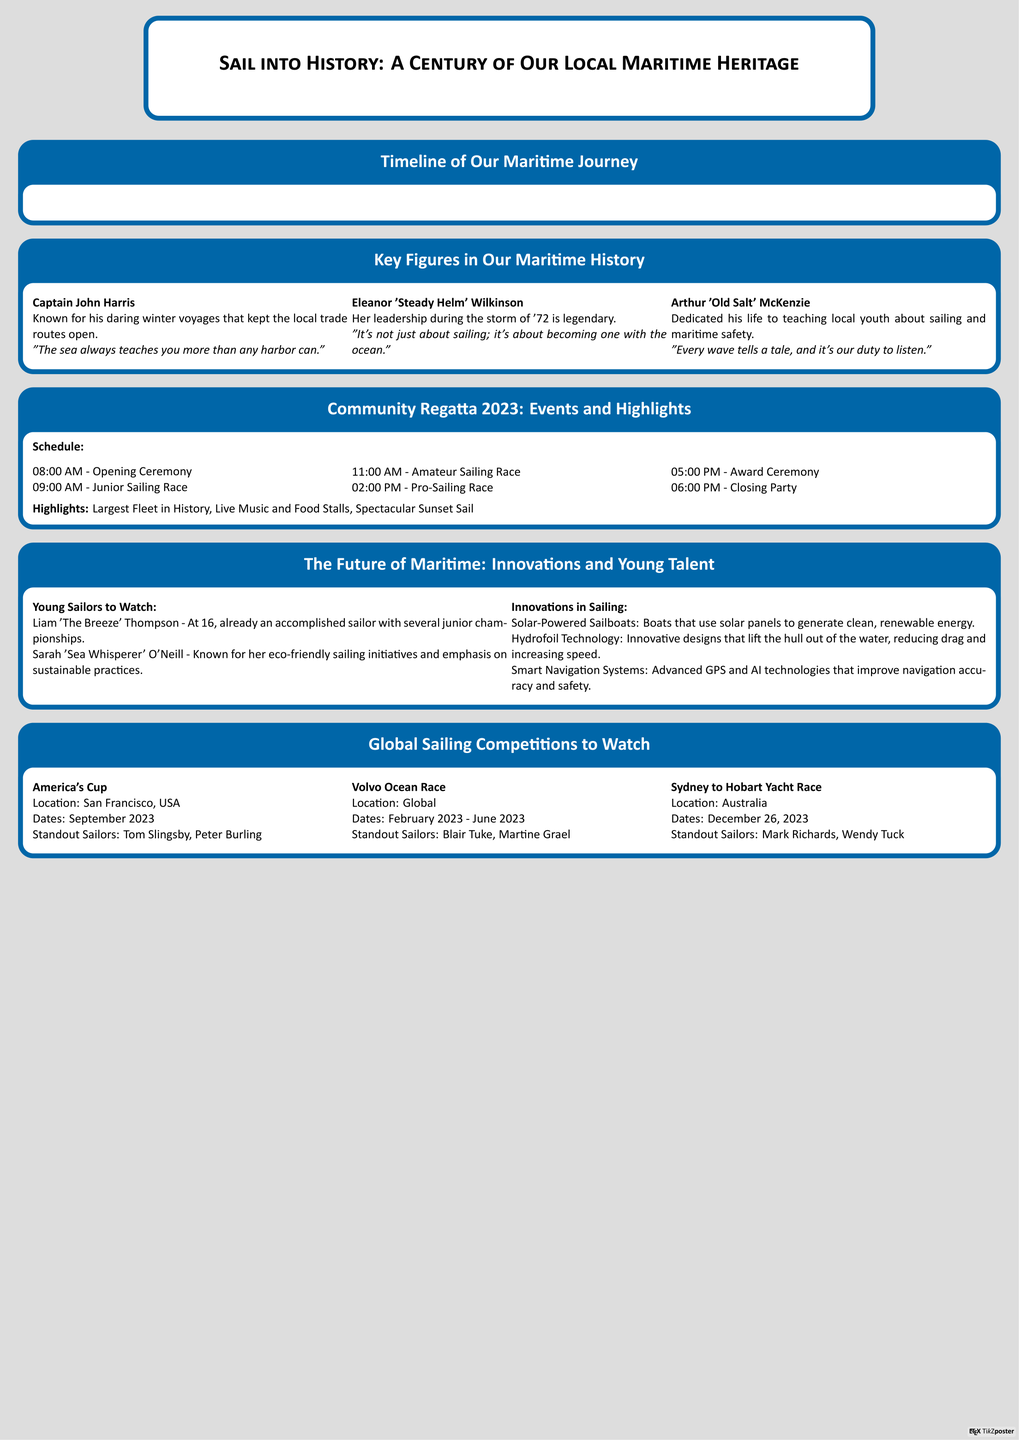What year was the Harborside Yacht Club founded? The founding year is listed in the timeline of the maritime journey, specifically under the first milestone.
Answer: 1923 Who is known for exceptional leadership during the storm of '72? The answer can be found within the key figures in maritime history section, specifically regarding Eleanor Wilkinson.
Answer: Eleanor 'Steady Helm' Wilkinson What event marks the centenary celebration of the Harborside Yacht Club? This information is found in the timeline, specifying the milestone related to the Harborside Yacht Club's centenary.
Answer: Centenary Celebrations of Harborside Yacht Club How many events are scheduled for the Community Regatta 2023? The schedule for events in the Community Regatta section provides a specific list of events that can be counted.
Answer: 6 Which innovation in sailing is focused on reducing drag? The document lists specific innovations and matches them to functions, regarding Hydrofoil Technology.
Answer: Hydrofoil Technology What does Liam Thompson aim to inspire as a young sailor? The achievements and reputation of the young sailors are highlighted in the section on young talent.
Answer: Championships When does the Sydney to Hobart Yacht Race take place? The date is specified in the section on global competitions, under the event details.
Answer: December 26, 2023 What color scheme is used in the poster design? The poster's description indicates the use of a specific nautical color scheme throughout its design elements.
Answer: Nautical colors Which competition is highlighted as happening in September 2023? The global sailing competitions section specifies the dates and details for each highlighted competition.
Answer: America's Cup 